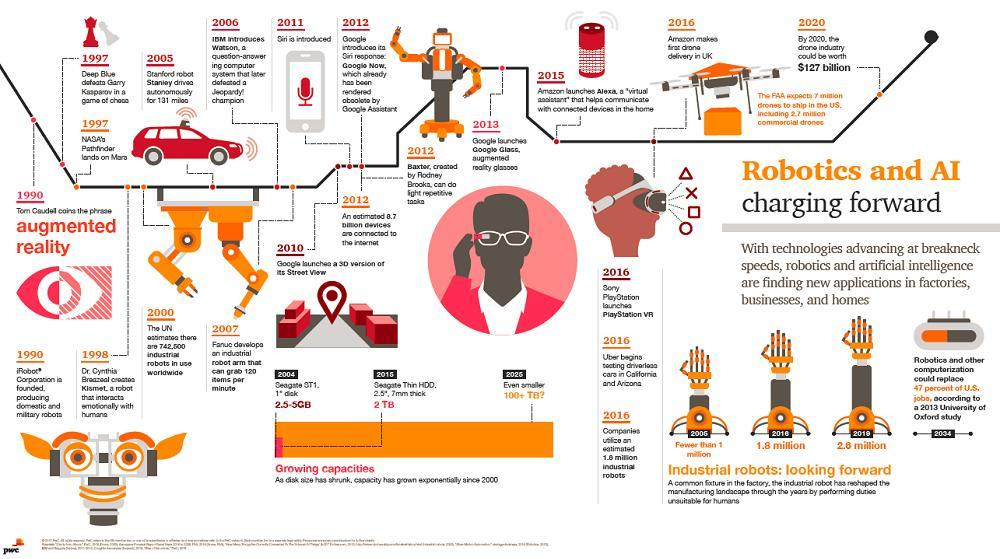What has made Siri obsolete
Answer the question with a short phrase. Google assistance where did Uber test driverless cars California and Arizona Who introduced augmented reality Tom Caudel the red car was driven by whom Stanford robot Stanley What is the red colour device shown that was launched in 2015 Alexa How many years after Siri was Alexa launched 4 